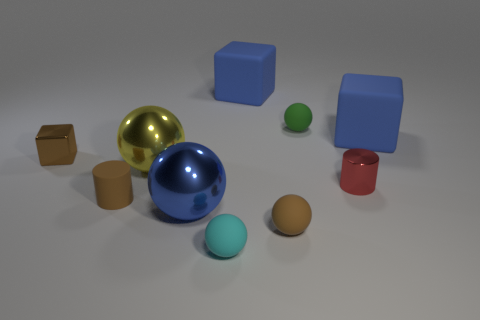Subtract all red cylinders. How many blue blocks are left? 2 Subtract all rubber blocks. How many blocks are left? 1 Subtract all brown balls. How many balls are left? 4 Subtract 1 spheres. How many spheres are left? 4 Subtract all green balls. Subtract all gray cylinders. How many balls are left? 4 Subtract all cubes. How many objects are left? 7 Add 5 red cylinders. How many red cylinders are left? 6 Add 7 cyan rubber cylinders. How many cyan rubber cylinders exist? 7 Subtract 0 yellow blocks. How many objects are left? 10 Subtract all brown things. Subtract all tiny objects. How many objects are left? 1 